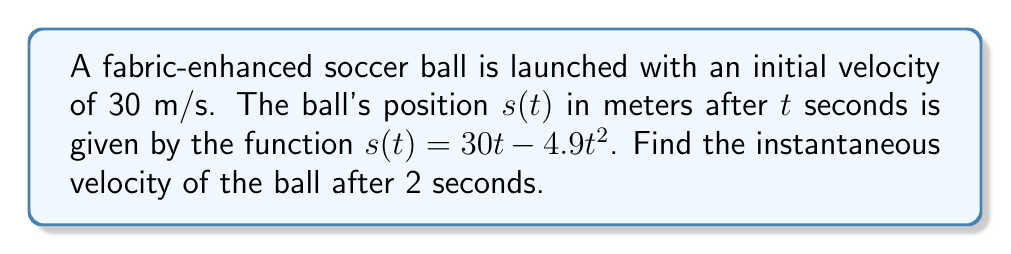Solve this math problem. To find the instantaneous velocity, we need to calculate the derivative of the position function $s(t)$ and then evaluate it at $t = 2$ seconds.

Step 1: Find the derivative of $s(t)$
The position function is $s(t) = 30t - 4.9t^2$
Using the power rule and constant multiple rule:
$$\frac{d}{dt}[s(t)] = \frac{d}{dt}[30t] - \frac{d}{dt}[4.9t^2]$$
$$v(t) = 30 - 9.8t$$

Step 2: Evaluate the velocity function at $t = 2$ seconds
$$v(2) = 30 - 9.8(2)$$
$$v(2) = 30 - 19.6$$
$$v(2) = 10.4$$

Therefore, the instantaneous velocity of the fabric-enhanced soccer ball after 2 seconds is 10.4 m/s.
Answer: 10.4 m/s 